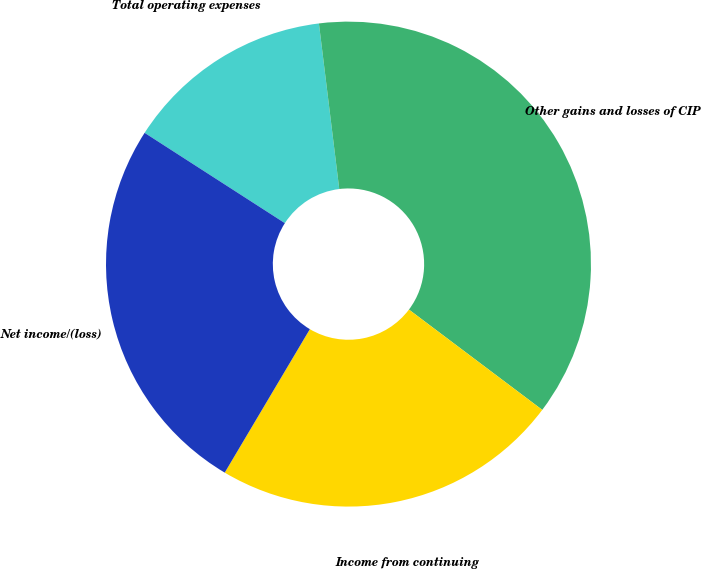Convert chart to OTSL. <chart><loc_0><loc_0><loc_500><loc_500><pie_chart><fcel>Total operating expenses<fcel>Other gains and losses of CIP<fcel>Income from continuing<fcel>Net income/(loss)<nl><fcel>13.95%<fcel>37.21%<fcel>23.26%<fcel>25.58%<nl></chart> 